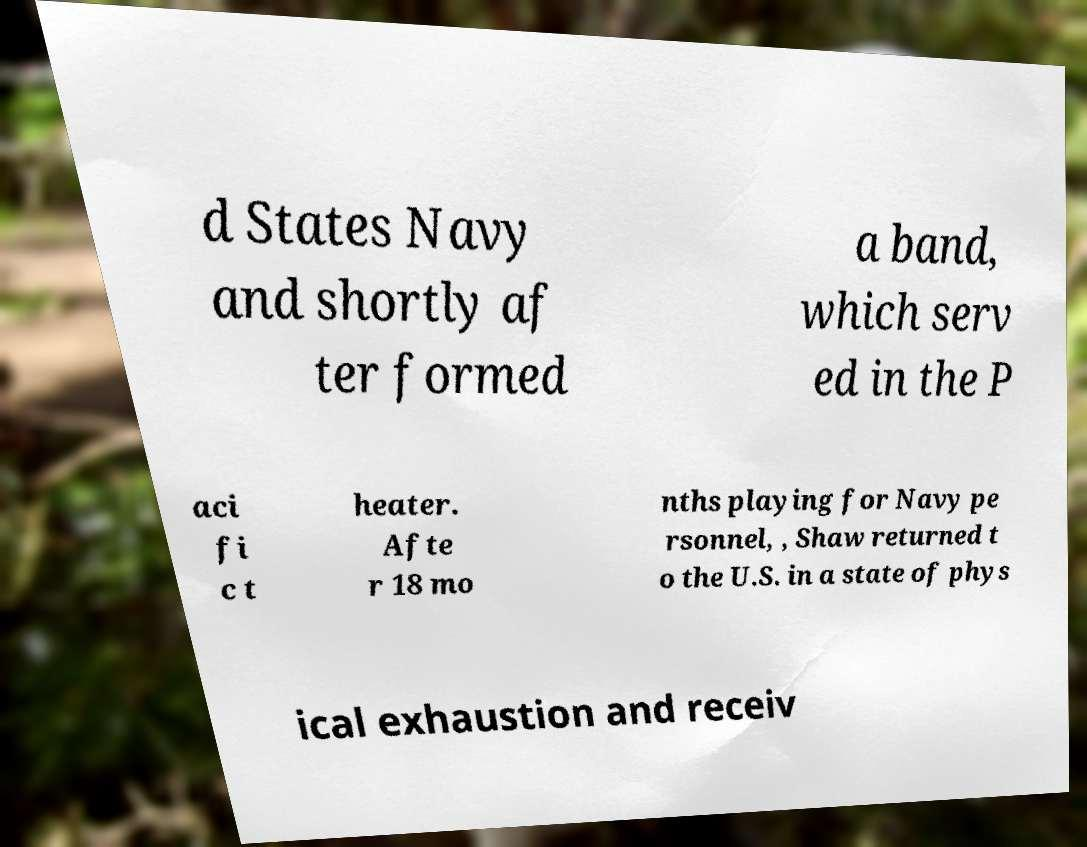Could you extract and type out the text from this image? d States Navy and shortly af ter formed a band, which serv ed in the P aci fi c t heater. Afte r 18 mo nths playing for Navy pe rsonnel, , Shaw returned t o the U.S. in a state of phys ical exhaustion and receiv 